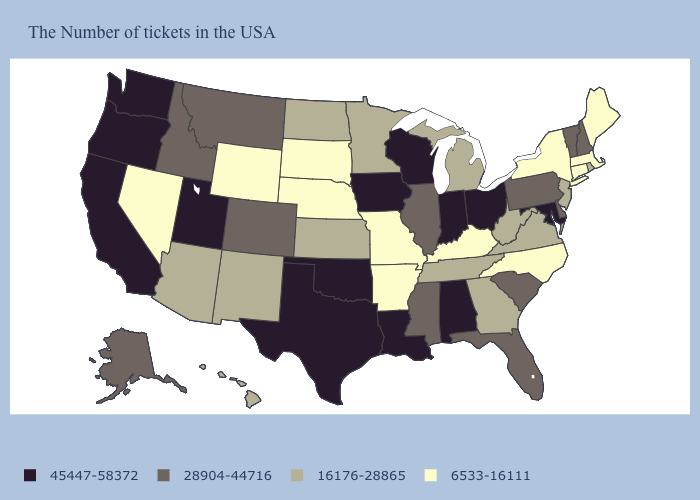Among the states that border Arkansas , does Mississippi have the lowest value?
Give a very brief answer. No. Does New York have the lowest value in the USA?
Write a very short answer. Yes. What is the value of Colorado?
Be succinct. 28904-44716. Does the first symbol in the legend represent the smallest category?
Answer briefly. No. What is the value of Ohio?
Concise answer only. 45447-58372. What is the value of Wisconsin?
Quick response, please. 45447-58372. Which states have the lowest value in the Northeast?
Concise answer only. Maine, Massachusetts, Connecticut, New York. What is the value of Michigan?
Answer briefly. 16176-28865. Which states have the lowest value in the USA?
Be succinct. Maine, Massachusetts, Connecticut, New York, North Carolina, Kentucky, Missouri, Arkansas, Nebraska, South Dakota, Wyoming, Nevada. Which states have the lowest value in the West?
Concise answer only. Wyoming, Nevada. What is the value of Utah?
Be succinct. 45447-58372. Name the states that have a value in the range 28904-44716?
Quick response, please. New Hampshire, Vermont, Delaware, Pennsylvania, South Carolina, Florida, Illinois, Mississippi, Colorado, Montana, Idaho, Alaska. What is the value of Alabama?
Give a very brief answer. 45447-58372. Does Maryland have the lowest value in the South?
Short answer required. No. What is the lowest value in states that border North Dakota?
Be succinct. 6533-16111. 